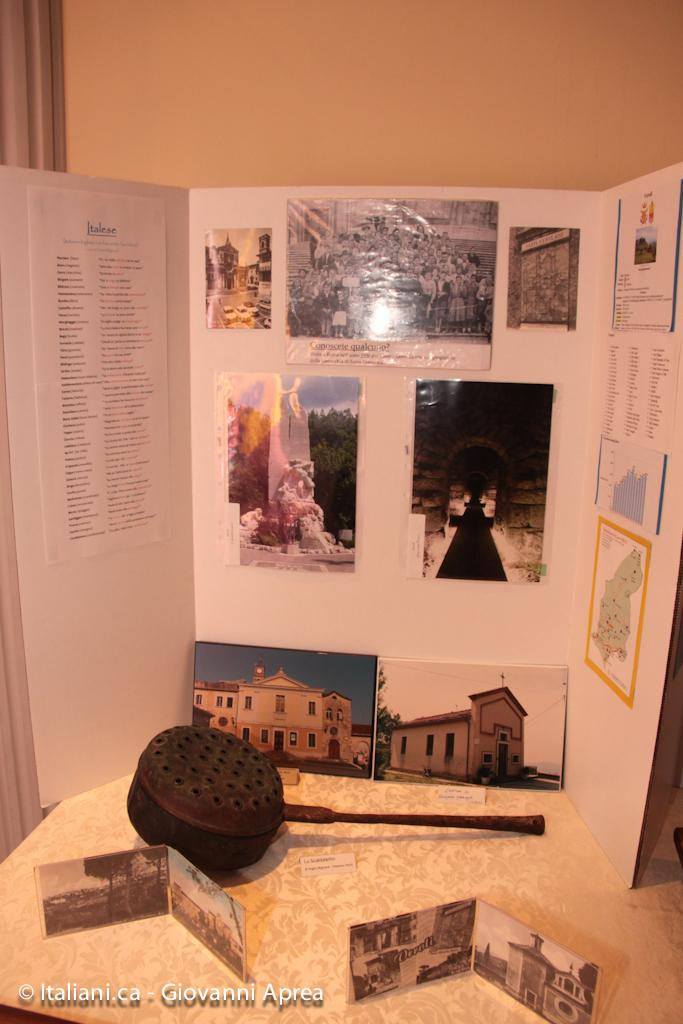What can be seen on the surface in the image? There are objects on a surface in the image. What type of information is displayed on the chart in the image? The chart in the image has images and text visible. What part of the room can be seen at the top of the image? The wall is visible at the top of the image. How much ink is required to fill the sack in the image? There is no sack or ink present in the image. What time of day is depicted in the image? The time of day cannot be determined from the image, as there are no clocks or indications of time. 